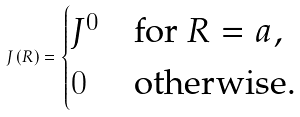<formula> <loc_0><loc_0><loc_500><loc_500>J \left ( R \right ) = \begin{cases} J ^ { 0 } & \text {for } R = a , \\ 0 & \text {otherwise.} \\ \end{cases}</formula> 